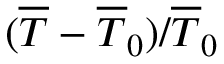<formula> <loc_0><loc_0><loc_500><loc_500>( \overline { T } - \overline { T } _ { 0 } ) / \overline { T } _ { 0 }</formula> 